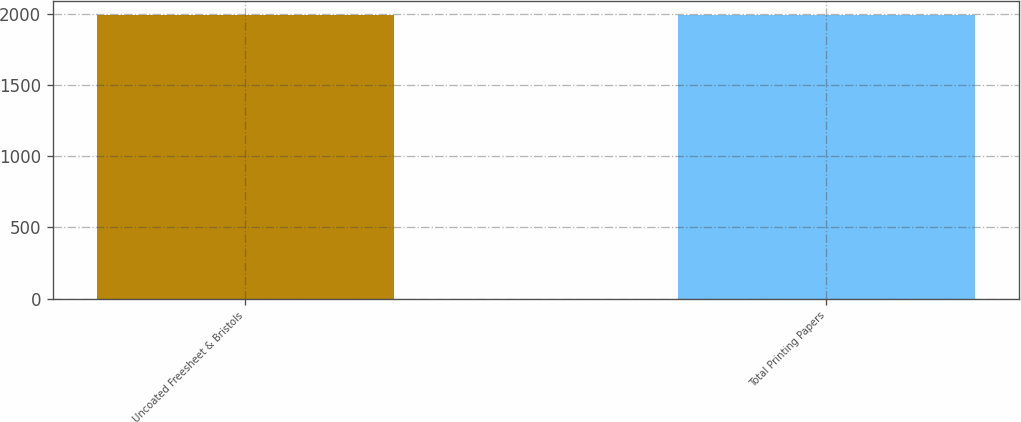Convert chart. <chart><loc_0><loc_0><loc_500><loc_500><bar_chart><fcel>Uncoated Freesheet & Bristols<fcel>Total Printing Papers<nl><fcel>1990<fcel>1990.1<nl></chart> 